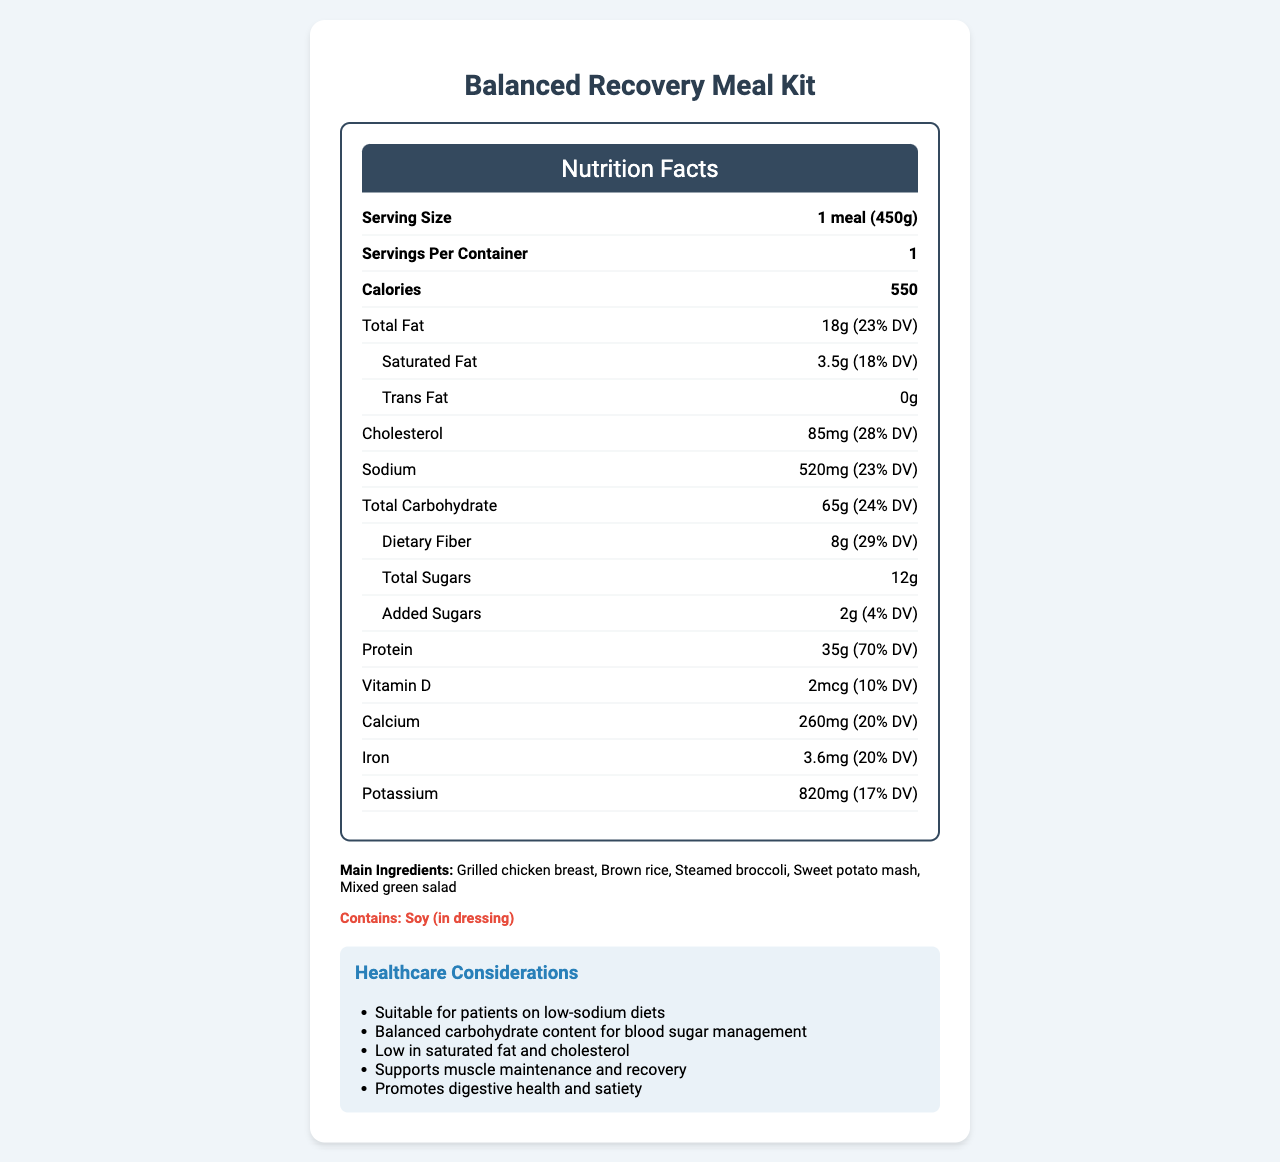what is the serving size? The serving size is directly listed under the "Serving Size" section in the document.
Answer: 1 meal (450g) how many calories are in one meal? The calories per meal are listed as 550 under the "Calories" section in the document.
Answer: 550 what is the total fat content? The total fat content is listed as 18g under the "Total Fat" section in the document.
Answer: 18g which ingredient is mentioned as an allergen? The allergen information mentions "Contains: Soy (in dressing)" under the allergens section.
Answer: Soy (in dressing) what is the shelf life of this meal? The shelf life is specified as "3 days when refrigerated" in the document.
Answer: 3 days when refrigerated which of the following is not a main ingredient? A. Grilled chicken breast B. Brown rice C. Mashed potatoes D. Mixed green salad Mashed potatoes are not listed in the main ingredients section. The listed ingredients are Grilled chicken breast, Brown rice, Steamed broccoli, Sweet potato mash, and Mixed green salad.
Answer: C what is the daily value percentage for dietary fiber? A. 18% B. 24% C. 29% D. 70% The daily value percentage for dietary fiber is listed as 29% under the "Dietary Fiber" section.
Answer: C is this meal suitable for patients on low-sodium diets? The healthcare considerations section mentions "Suitable for patients on low-sodium diets."
Answer: Yes describe the main idea of the document. This explanation summarizes the key points covered by the nutrition label and healthcare considerations included in the document.
Answer: The document provides the nutritional facts and healthcare considerations for a Balanced Recovery Meal Kit, including serving size, calorie content, macronutrients, and vitamins, along with preparation instructions, shelf life, and ingredient information. It also highlights that the meal is suitable for various dietary needs such as low-sodium, diabetes-friendly, heart-healthy, high-protein, and fiber-rich diets. does the meal contain any trans fats? The trans fat content is listed as 0g under the "Trans Fat" section in the document.
Answer: No what is the daily value percentage for protein? The daily value percentage for protein is listed as 70% under the "Protein" section.
Answer: 70% which healthcare consideration supports muscle maintenance and recovery? The healthcare considerations section mentions "Supports muscle maintenance and recovery" under the "high protein" consideration.
Answer: High protein what is the amount of cholesterol in the meal? The amount of cholesterol is listed as 85mg under the "Cholesterol" section in the document.
Answer: 85mg are there any details about the sustainability of the packaging? The document mentions that the packaging is made from 30% recycled materials in the sustainability information section.
Answer: Yes what is the preparation time for the meal? The preparation instructions state to "Microwave for 3-4 minutes" or until the internal temperature reaches 165°F (74°C).
Answer: Microwave for 3-4 minutes what type of certification does the kitchen have? The quality control section mentions that the meal is prepared in a HACCP-certified kitchen.
Answer: HACCP-certified what is the sodium content per meal? The sodium content per meal is listed as 520mg under the "Sodium" section in the document.
Answer: 520mg what is the main type of packaging used? The packaging section specifies that the meal comes in a BPA-free, microwave-safe container.
Answer: BPA-free, microwave-safe container what is the unidentified ingredient in the dressing? The document states that the dressing contains soy but does not provide information about any other ingredients in the dressing.
Answer: Cannot be determined 